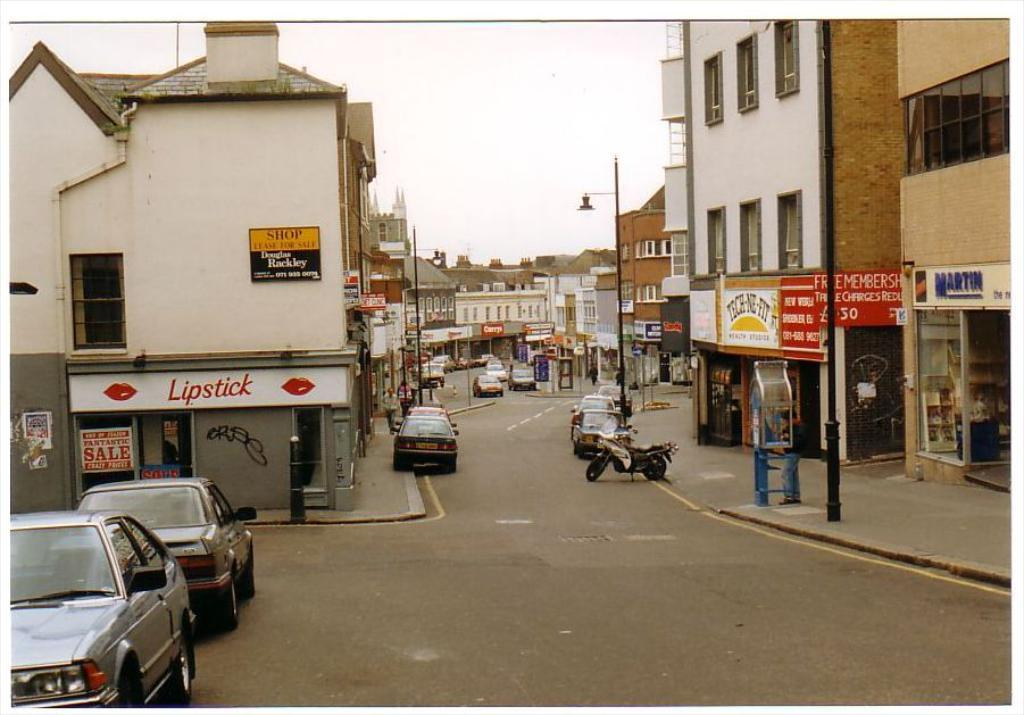What can be seen in the foreground of the image? There are vehicles on the road in the foreground of the image. What structures are located on either side of the road? There are buildings on either side of the road. What objects are visible in the image besides the vehicles and buildings? There are poles and boards visible in the image. What is visible at the top of the image? The sky is visible at the top of the image. What type of hate can be seen on the boards in the image? There is no hate present in the image; the boards are likely used for advertising or informational purposes. How many oranges are visible on the poles in the image? There are no oranges present in the image; the poles are likely used for electrical or communication purposes. 